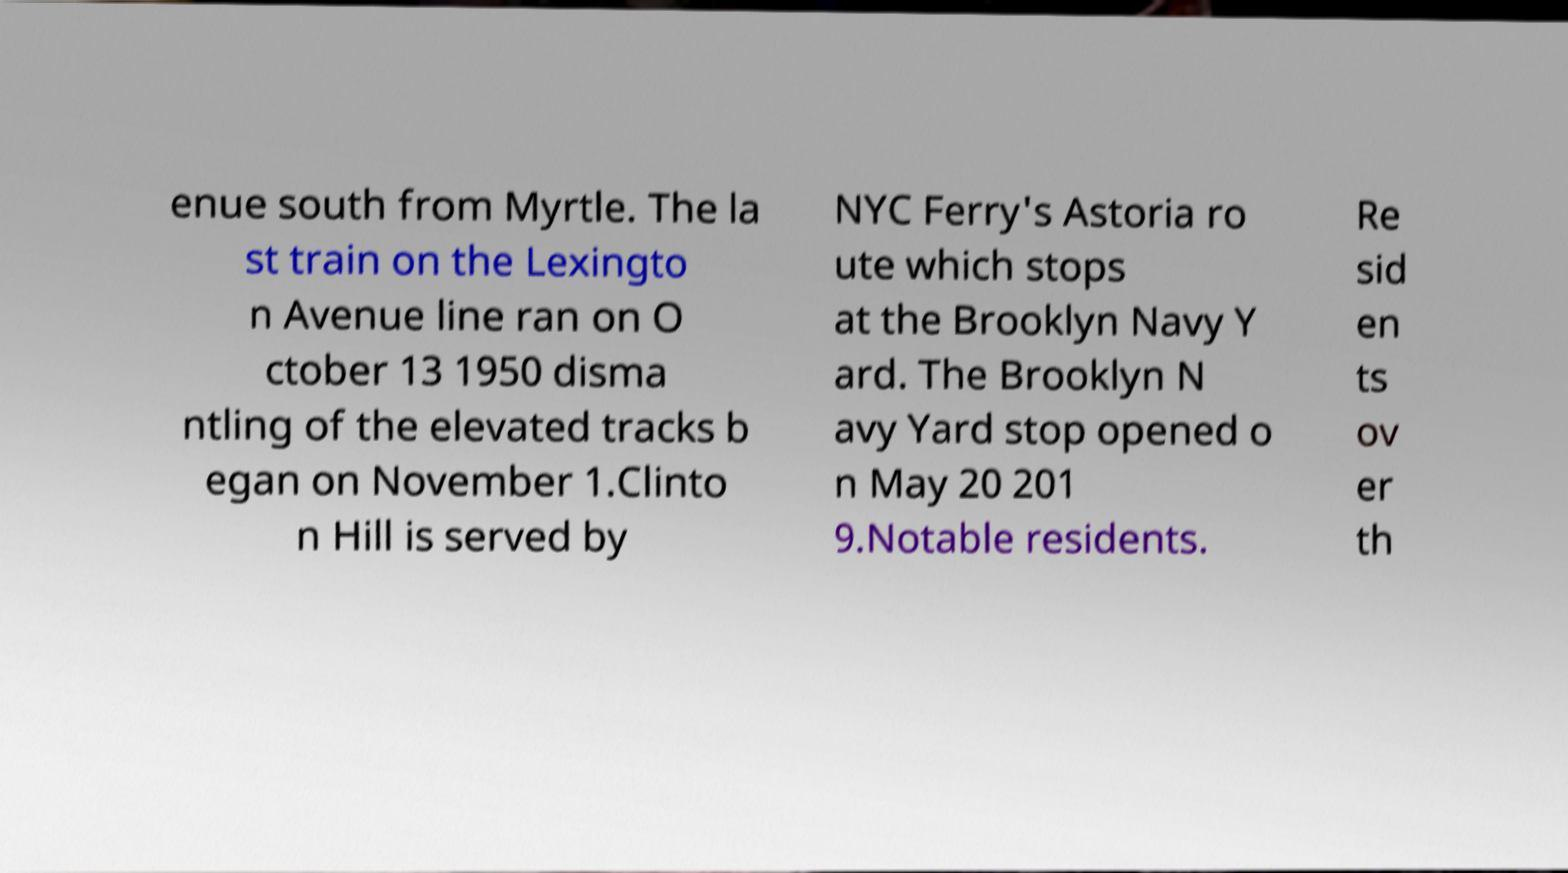Could you extract and type out the text from this image? enue south from Myrtle. The la st train on the Lexingto n Avenue line ran on O ctober 13 1950 disma ntling of the elevated tracks b egan on November 1.Clinto n Hill is served by NYC Ferry's Astoria ro ute which stops at the Brooklyn Navy Y ard. The Brooklyn N avy Yard stop opened o n May 20 201 9.Notable residents. Re sid en ts ov er th 